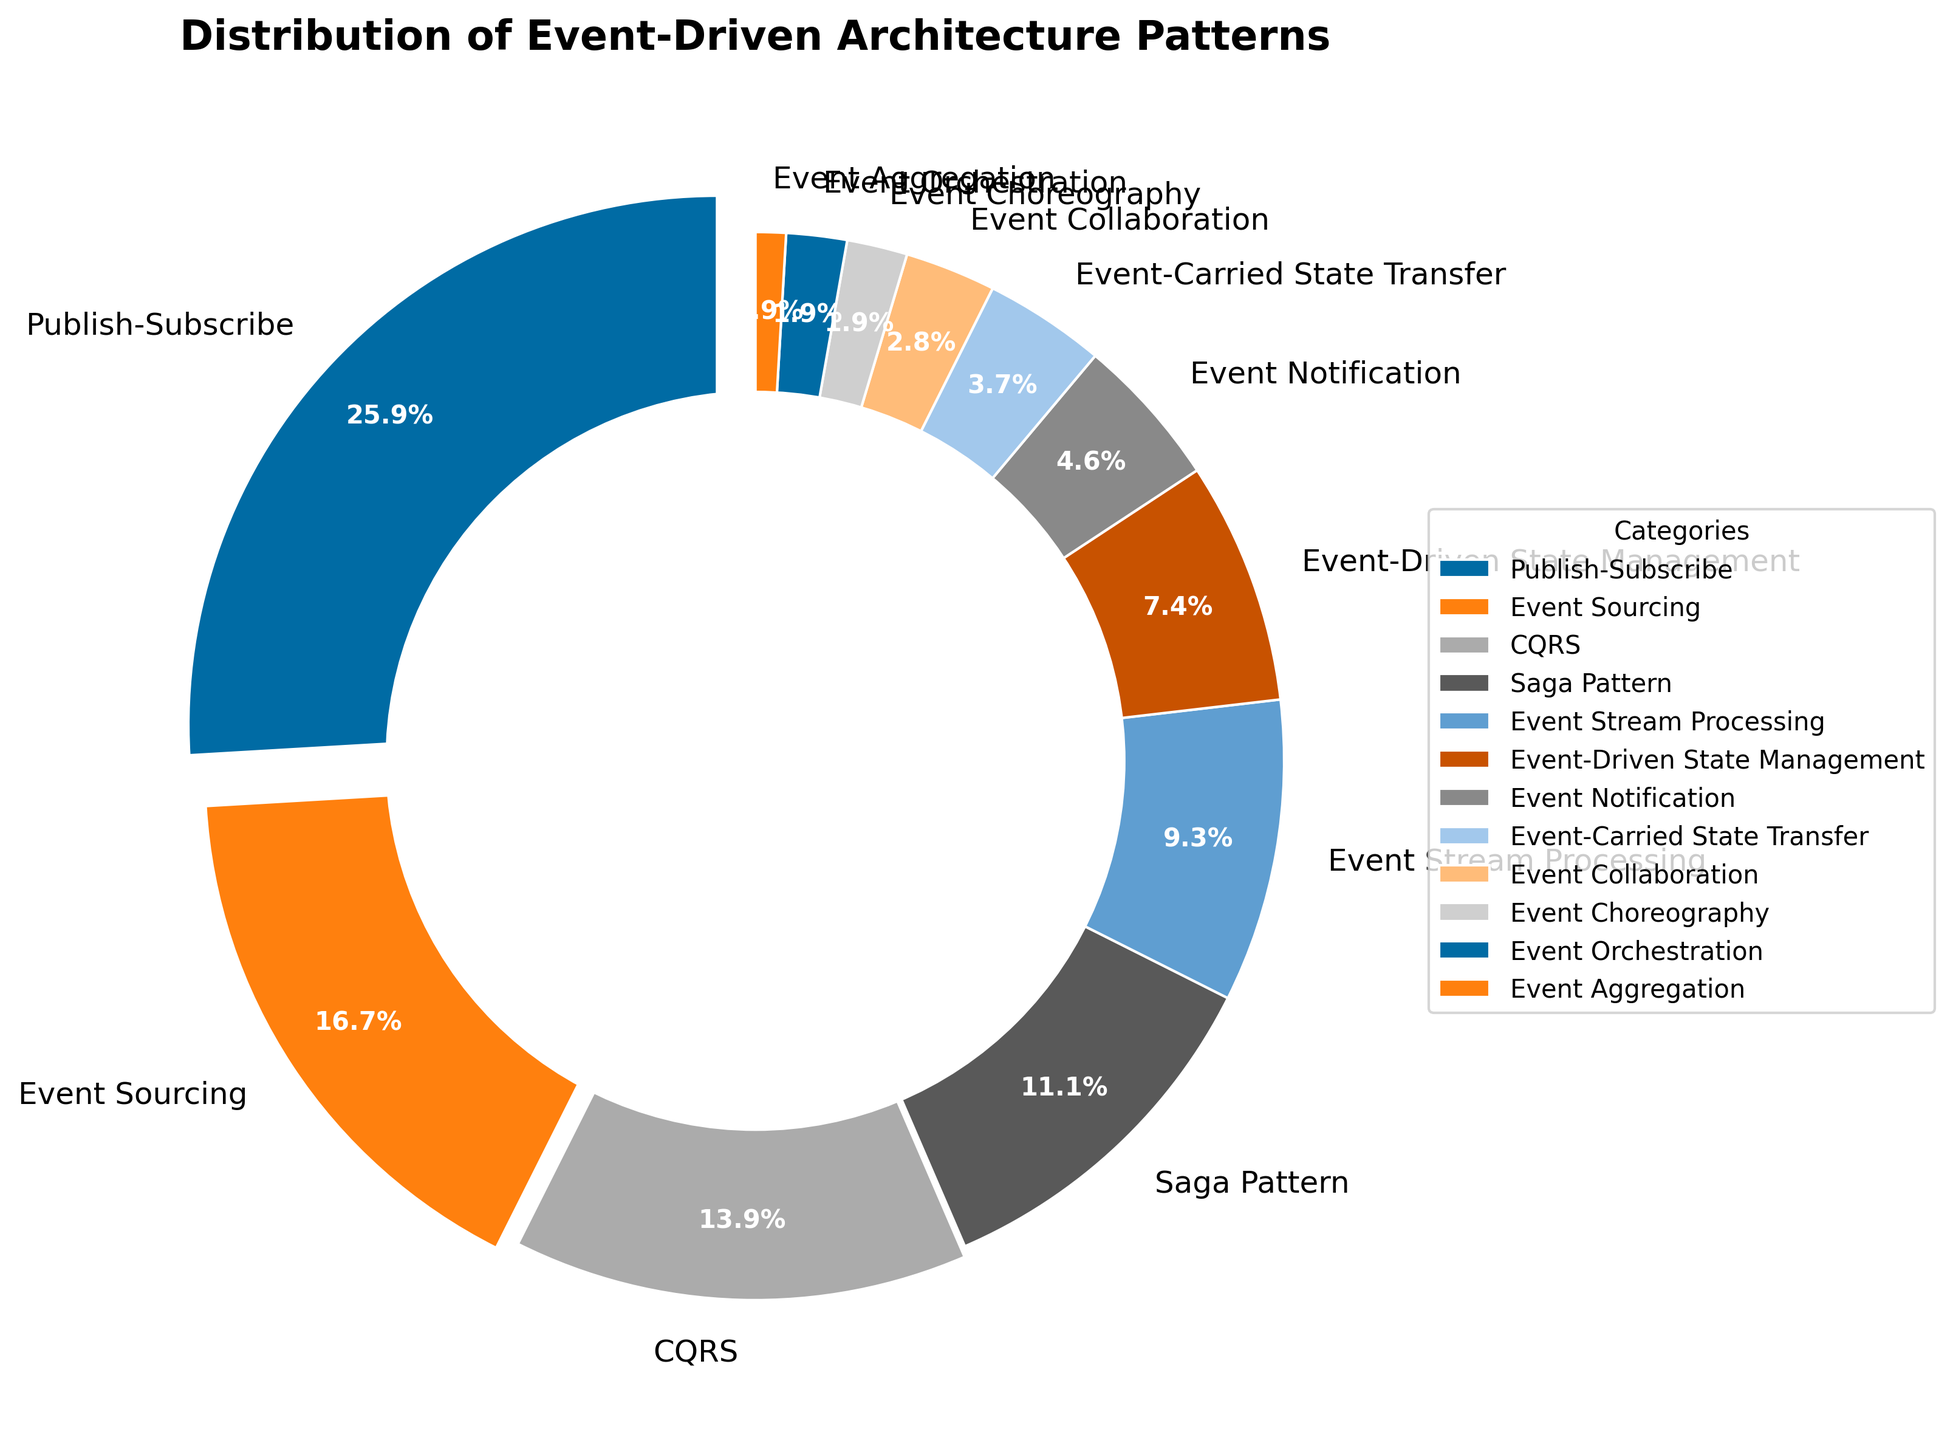Which event-driven architecture pattern has the highest percentage? The segment with the highest percentage is "Publish-Subscribe." It is at the top of the sorted list and has the highest percentage, which is visually emphasized with a bigger explosion effect.
Answer: Publish-Subscribe Which three patterns have the highest percentages and how much do they collectively contribute? The three patterns with the highest percentages are Publish-Subscribe (28%), Event Sourcing (18%), and CQRS (15%). Adding these together: 28 + 18 + 15 = 61.
Answer: 61% What is the difference in percentage between the Publish-Subscribe and Saga Pattern? Publish-Subscribe has 28% and Saga Pattern has 12%. The difference is 28 - 12 = 16.
Answer: 16% Which patterns are visually least prominent and what are their respective percentages? The least prominent patterns, indicated by the smallest segments, are Event Aggregation (1%), Event Choreography (2%), and Event Orchestration (2%).
Answer: Event Aggregation (1%), Event Choreography (2%), Event Orchestration (2%) Among Event Notification and Event Collaboration, which pattern has a higher percentage? Event Notification has 5% and Event Collaboration has 3%. Therefore, Event Notification has a higher percentage.
Answer: Event Notification What is the combined percentage of all patterns with less than 5%? Patterns with less than 5% are Event-Carried State Transfer (4%), Event Collaboration (3%), Event Orchestration (2%), Event Choreography (2%), and Event Aggregation (1%). Adding these together: 4 + 3 + 2 + 2 + 1 = 12.
Answer: 12% How does the event-driven state management percentage compare to event stream processing? Event-Driven State Management is 8% and Event Stream Processing is 10%. Comparatively, Event Stream Processing has a higher percentage.
Answer: Event Stream Processing Which pattern is directly below CQRS in the list and what is its percentage? Directly below CQRS (15%) is Saga Pattern, which has 12%.
Answer: Saga Pattern, 12% Which of the top 3 patterns has the smallest difference in percentage among them, and what is that difference? The top three patterns are Publish-Subscribe (28%), Event Sourcing (18%), and CQRS (15%). The smallest difference is between Event Sourcing and CQRS, which is 18 - 15 = 3.
Answer: Event Sourcing and CQRS, 3 What is the ratio of Publish-Subscribe percentage to Event Aggregation percentage? Publish-Subscribe is 28% and Event Aggregation is 1%. The ratio is 28:1.
Answer: 28:1 